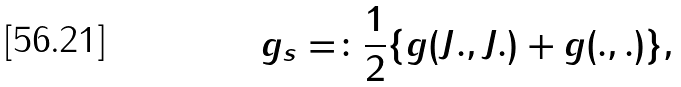<formula> <loc_0><loc_0><loc_500><loc_500>g _ { s } = \colon \frac { 1 } { 2 } \{ g ( J . , J . ) + g ( . , . ) \} ,</formula> 